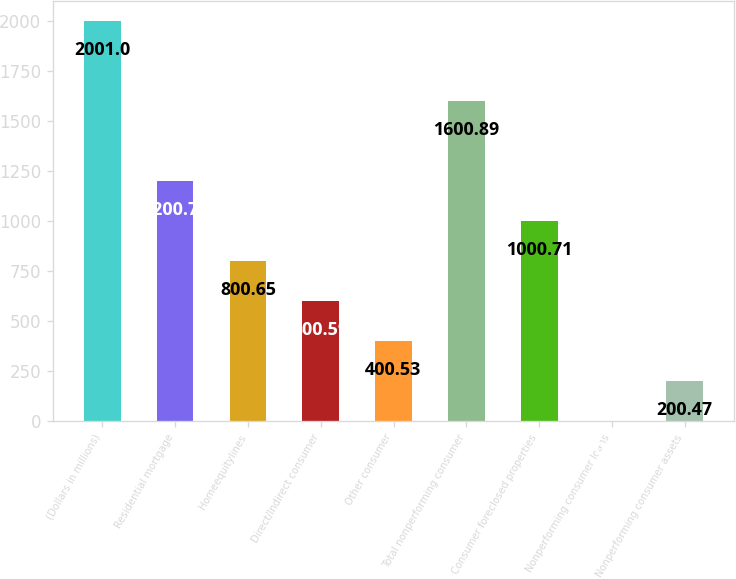Convert chart to OTSL. <chart><loc_0><loc_0><loc_500><loc_500><bar_chart><fcel>(Dollars in millions)<fcel>Residential mortgage<fcel>Homeequitylines<fcel>Direct/Indirect consumer<fcel>Other consumer<fcel>Total nonperforming consumer<fcel>Consumer foreclosed properties<fcel>Nonperforming consumer loans<fcel>Nonperforming consumer assets<nl><fcel>2001<fcel>1200.77<fcel>800.65<fcel>600.59<fcel>400.53<fcel>1600.89<fcel>1000.71<fcel>0.41<fcel>200.47<nl></chart> 